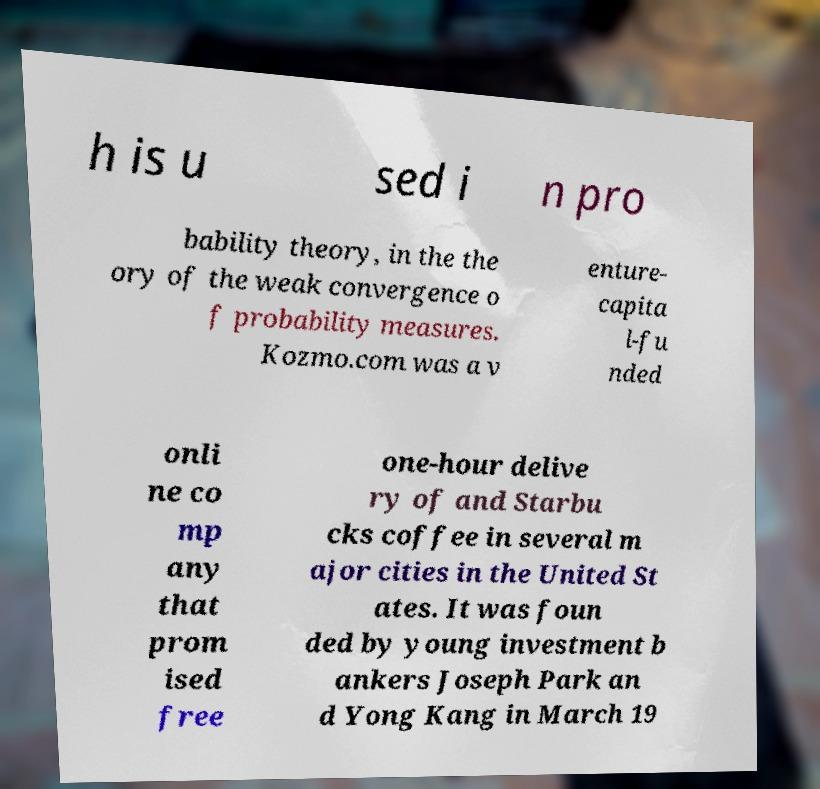Could you extract and type out the text from this image? h is u sed i n pro bability theory, in the the ory of the weak convergence o f probability measures. Kozmo.com was a v enture- capita l-fu nded onli ne co mp any that prom ised free one-hour delive ry of and Starbu cks coffee in several m ajor cities in the United St ates. It was foun ded by young investment b ankers Joseph Park an d Yong Kang in March 19 